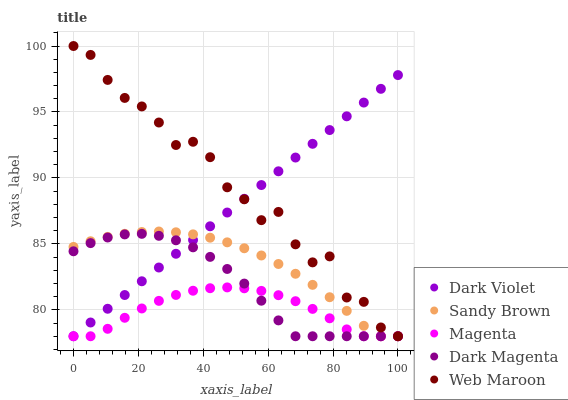Does Magenta have the minimum area under the curve?
Answer yes or no. Yes. Does Web Maroon have the maximum area under the curve?
Answer yes or no. Yes. Does Sandy Brown have the minimum area under the curve?
Answer yes or no. No. Does Sandy Brown have the maximum area under the curve?
Answer yes or no. No. Is Dark Violet the smoothest?
Answer yes or no. Yes. Is Web Maroon the roughest?
Answer yes or no. Yes. Is Magenta the smoothest?
Answer yes or no. No. Is Magenta the roughest?
Answer yes or no. No. Does Web Maroon have the lowest value?
Answer yes or no. Yes. Does Web Maroon have the highest value?
Answer yes or no. Yes. Does Sandy Brown have the highest value?
Answer yes or no. No. Does Magenta intersect Dark Violet?
Answer yes or no. Yes. Is Magenta less than Dark Violet?
Answer yes or no. No. Is Magenta greater than Dark Violet?
Answer yes or no. No. 